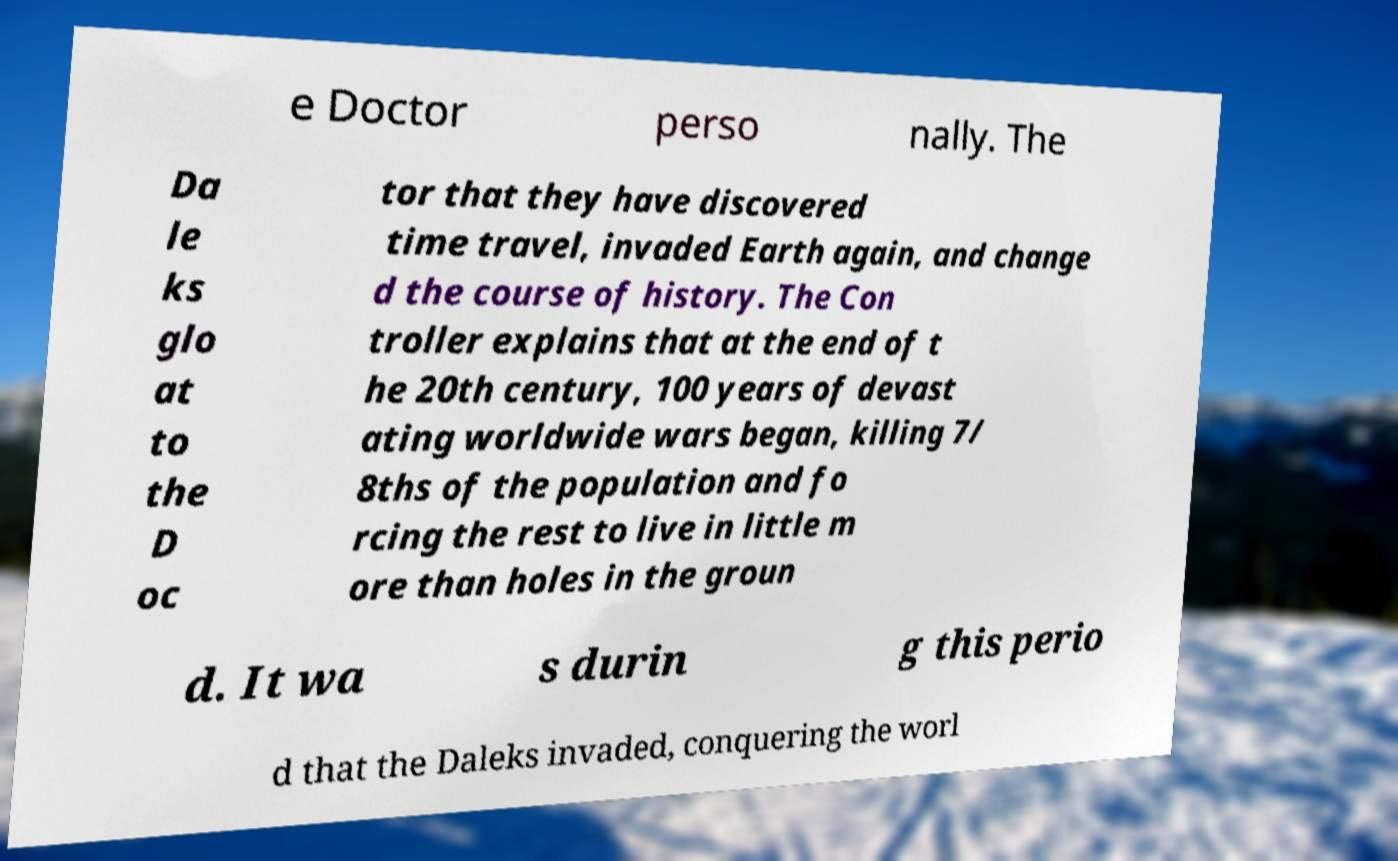Can you read and provide the text displayed in the image?This photo seems to have some interesting text. Can you extract and type it out for me? e Doctor perso nally. The Da le ks glo at to the D oc tor that they have discovered time travel, invaded Earth again, and change d the course of history. The Con troller explains that at the end of t he 20th century, 100 years of devast ating worldwide wars began, killing 7/ 8ths of the population and fo rcing the rest to live in little m ore than holes in the groun d. It wa s durin g this perio d that the Daleks invaded, conquering the worl 